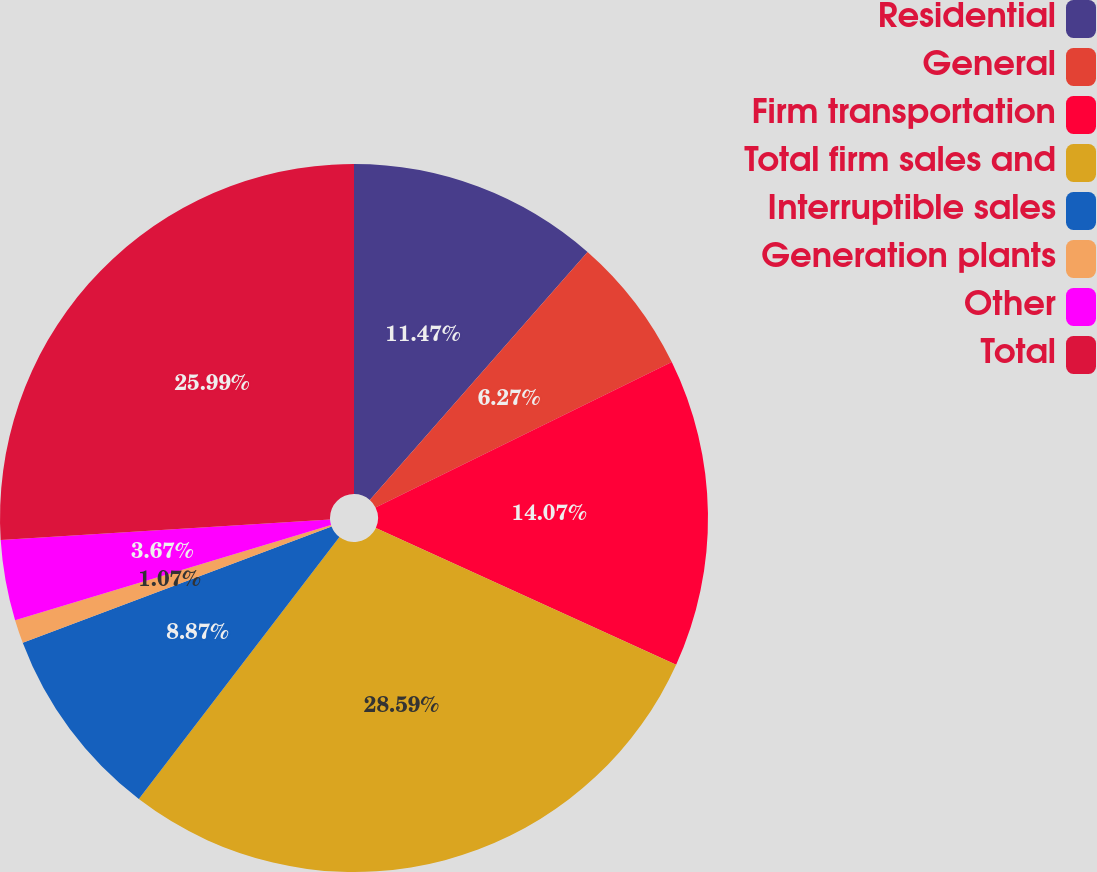<chart> <loc_0><loc_0><loc_500><loc_500><pie_chart><fcel>Residential<fcel>General<fcel>Firm transportation<fcel>Total firm sales and<fcel>Interruptible sales<fcel>Generation plants<fcel>Other<fcel>Total<nl><fcel>11.47%<fcel>6.27%<fcel>14.07%<fcel>28.6%<fcel>8.87%<fcel>1.07%<fcel>3.67%<fcel>26.0%<nl></chart> 